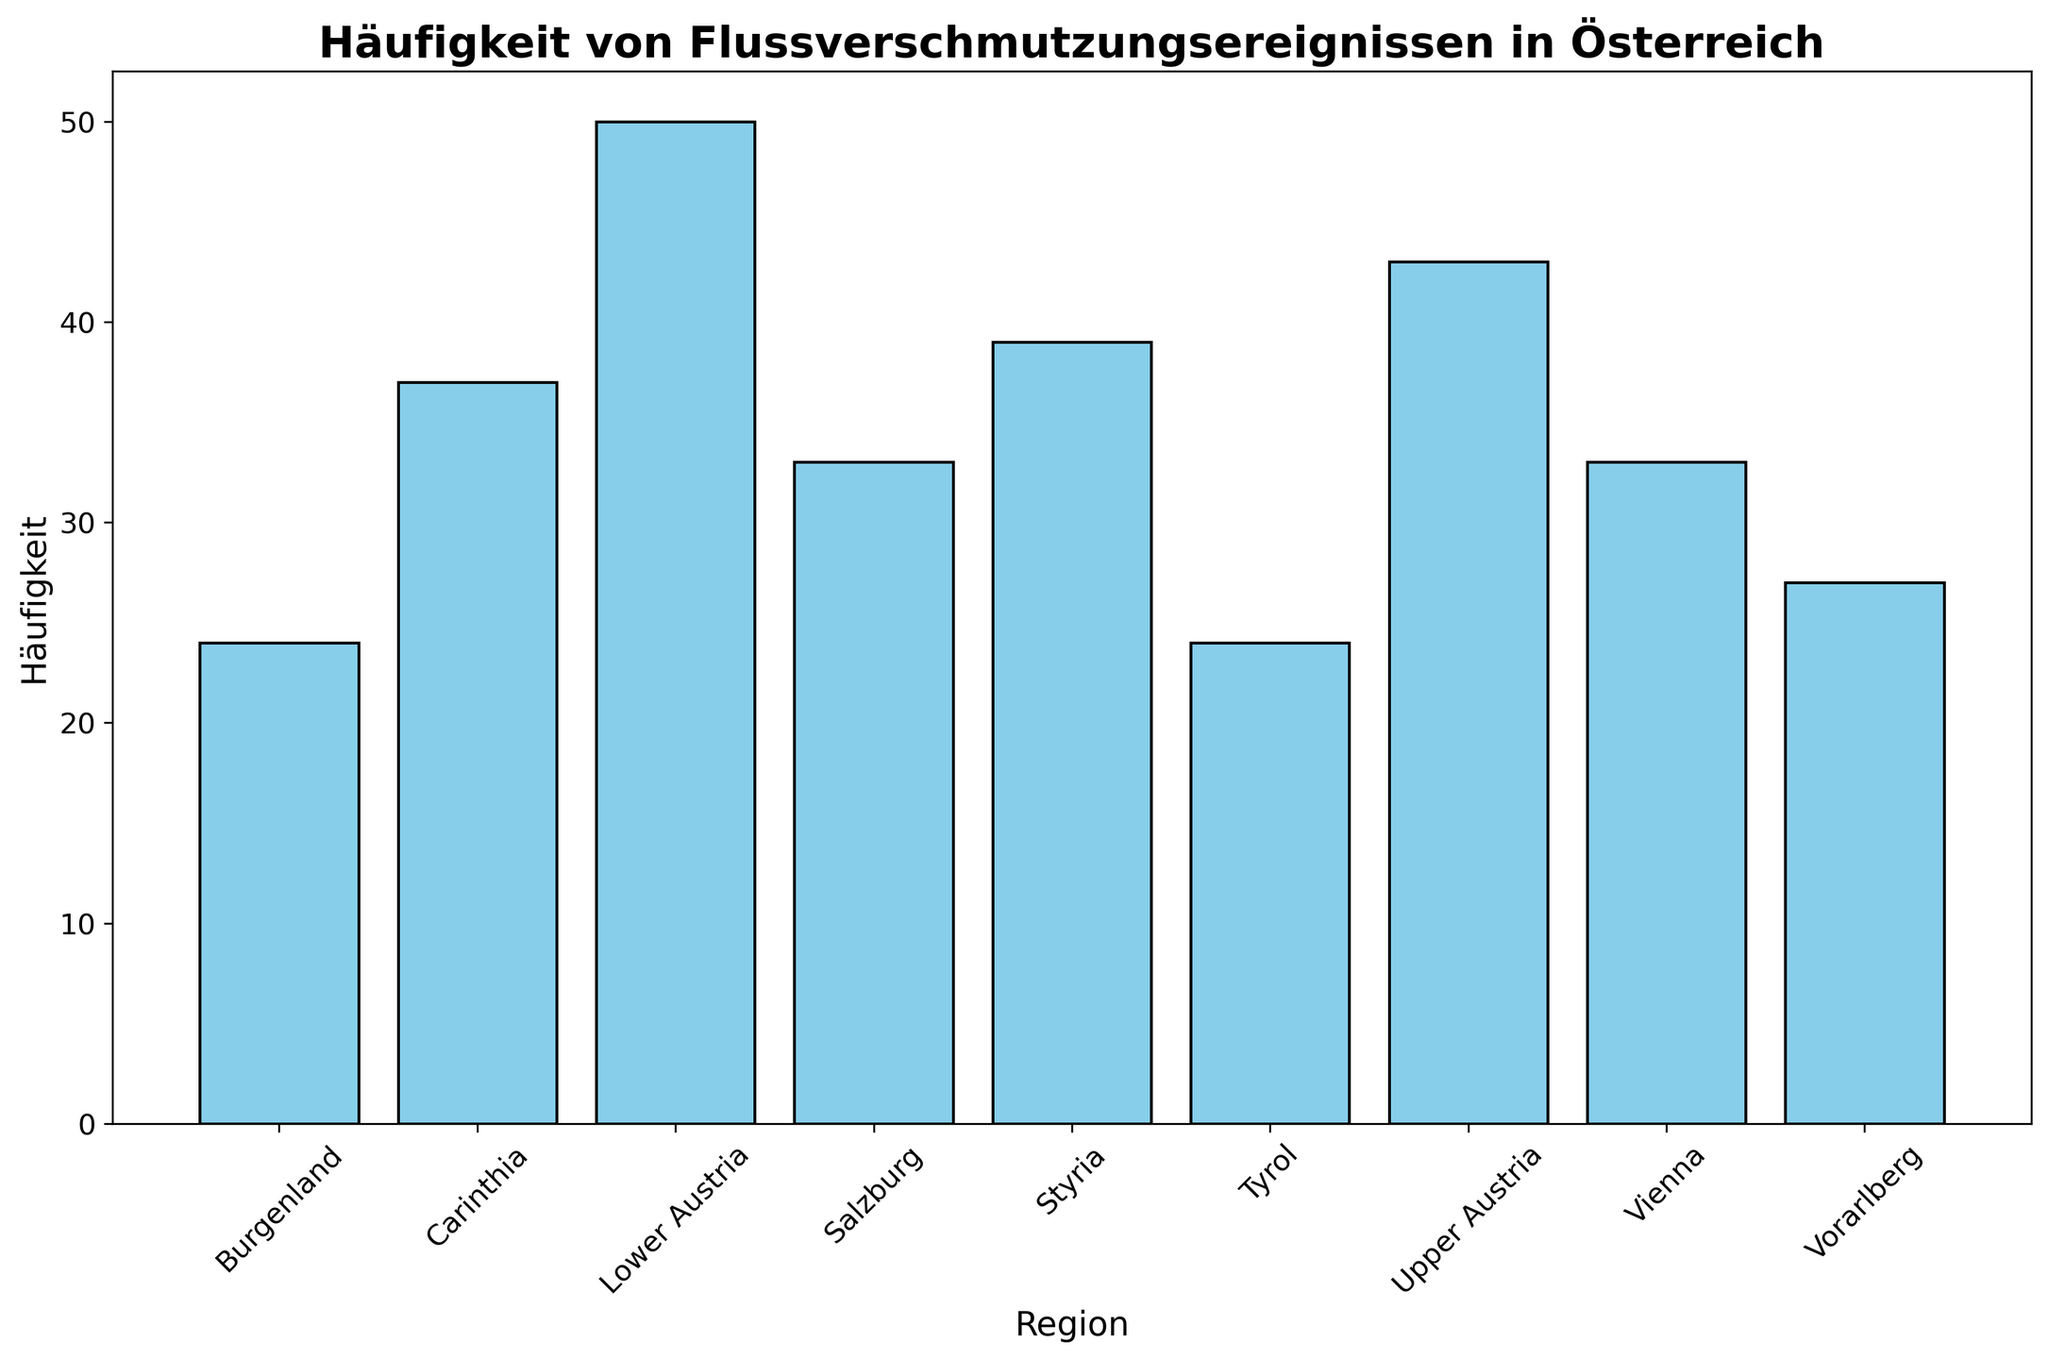Was ist die häufigste Flussverschmutzungsregion in Österreich? Betrachtet man das Histogramm, erkennt man, dass "Lower Austria" die höchsten Balken hat. Dies bedeutet, dass es die höchste Häufigkeit von Flussverschmutzungsereignissen hat.
Answer: Lower Austria Welche Region hat die niedrigste Häufigkeit von Flussverschmutzungsereignissen? Von allen Balken im Histogramm ist derjenige für "Burgenland" der kürzeste, was bedeutet, dass es die niedrigste Häufigkeit hat.
Answer: Burgenland Wie groß ist der Unterschied in der Häufigkeit zwischen Vienna und Tyrol? Die Höhe des Balkens für "Vienna" ist 33 und für "Tyrol" ist 24. Der Unterschied in der Häufigkeit beträgt 33 - 24 = 9.
Answer: 9 Vergleiche die Häufigkeit zwischen Upper Austria und Carinthia. Welche Region hat mehr Ereignisse? Im Histogramm ist der Balken für "Upper Austria" höher als der für "Carinthia", was bedeutet, dass "Upper Austria" mehr Ereignisse hat.
Answer: Upper Austria Was ist die durchschnittliche Häufigkeit von Flussverschmutzungsereignissen in allen Regionen? Um den Durchschnitt zu berechnen, summieren wir die Gesamtzahl der Ereignisse in allen Regionen und teilen durch die Anzahl der Regionen: (33+50+43+39+37+33+24+27+24)/9 = 310/9 = ca. 34,44
Answer: 34,44 Welcher Balken hat eine deutlich dunklere Färbung? Alle Balken haben eine gleichmäßige blaue Färbung, es gibt keine, die deutlich dunkler erscheint.
Answer: Keine Wie viele Regionen haben eine Häufigkeit über 35? Durch das Betrachten der Balkenhöhen sehen wir, dass nur "Lower Austria" (50) und "Upper Austria" (43) eine Häufigkeit über 35 haben.
Answer: 2 Was ist die Summe der Häufigkeiten von Vienna und Salzburg? Der Balken für "Vienna" ist 33 und der für "Salzburg" ist 33. Die Summe ist daher 33 + 33 = 66.
Answer: 66 